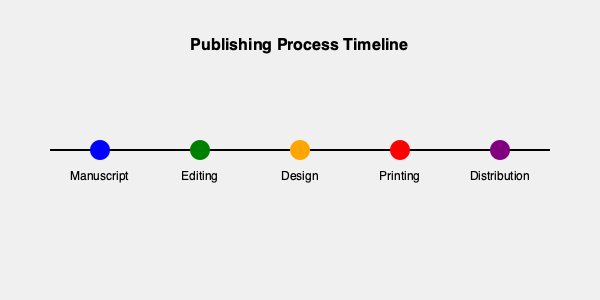In the publishing process timeline, which stage immediately follows the manuscript submission and is crucial for refining the author's work? To answer this question, we need to analyze the publishing process timeline shown in the illustration:

1. The timeline starts with the "Manuscript" stage, represented by the blue circle.
2. Moving from left to right, we can see the progression of the publishing process.
3. The stage immediately following the "Manuscript" is represented by the green circle.
4. This green circle is labeled "Editing."
5. Editing is indeed a crucial stage for refining the author's work, as it involves:
   - Reviewing the manuscript for content, structure, and style
   - Suggesting improvements and revisions
   - Ensuring the manuscript meets the publisher's standards
6. After editing, the process continues with Design, Printing, and Distribution stages.

Therefore, the stage that immediately follows manuscript submission and is crucial for refining the author's work is the Editing stage.
Answer: Editing 